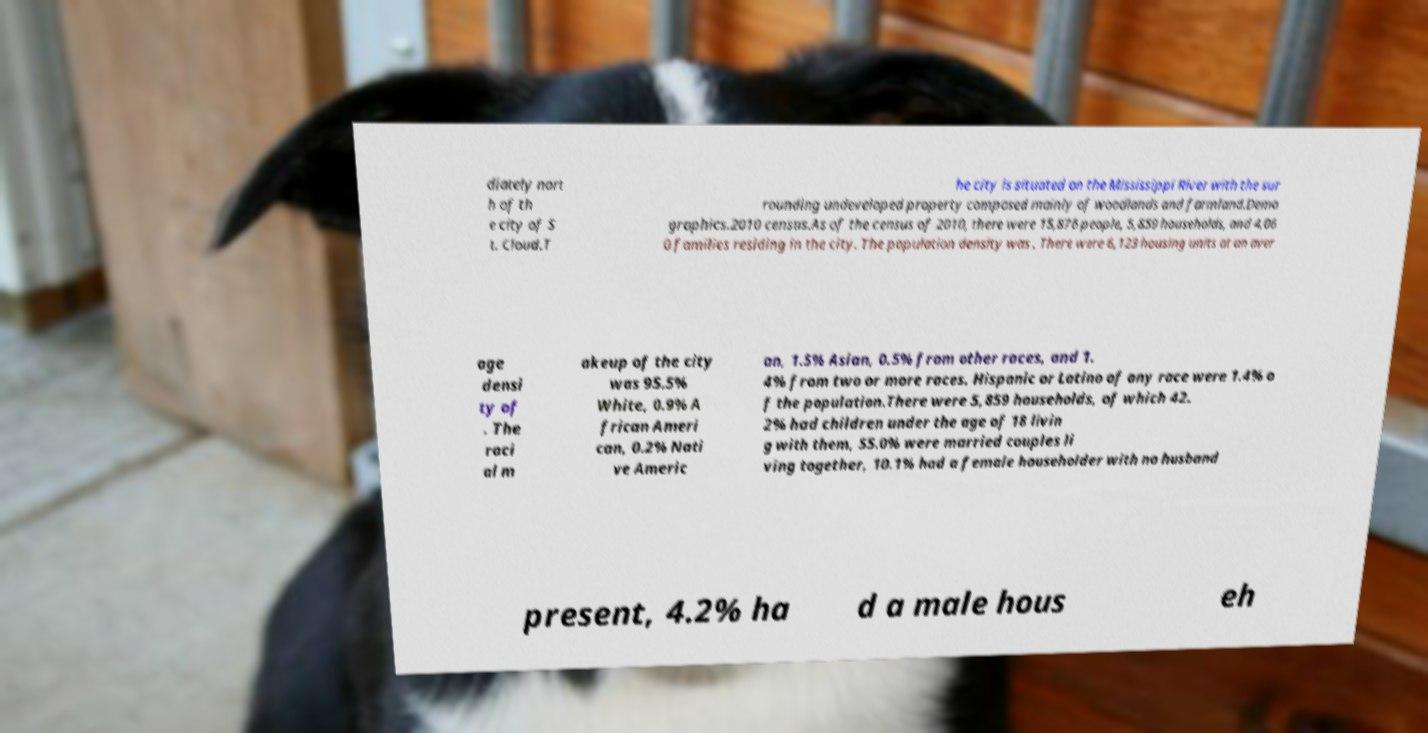What messages or text are displayed in this image? I need them in a readable, typed format. diately nort h of th e city of S t. Cloud.T he city is situated on the Mississippi River with the sur rounding undeveloped property composed mainly of woodlands and farmland.Demo graphics.2010 census.As of the census of 2010, there were 15,876 people, 5,859 households, and 4,06 0 families residing in the city. The population density was . There were 6,123 housing units at an aver age densi ty of . The raci al m akeup of the city was 95.5% White, 0.9% A frican Ameri can, 0.2% Nati ve Americ an, 1.5% Asian, 0.5% from other races, and 1. 4% from two or more races. Hispanic or Latino of any race were 1.4% o f the population.There were 5,859 households, of which 42. 2% had children under the age of 18 livin g with them, 55.0% were married couples li ving together, 10.1% had a female householder with no husband present, 4.2% ha d a male hous eh 